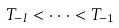<formula> <loc_0><loc_0><loc_500><loc_500>T _ { - I } < \cdot \cdot \cdot < T _ { - 1 }</formula> 